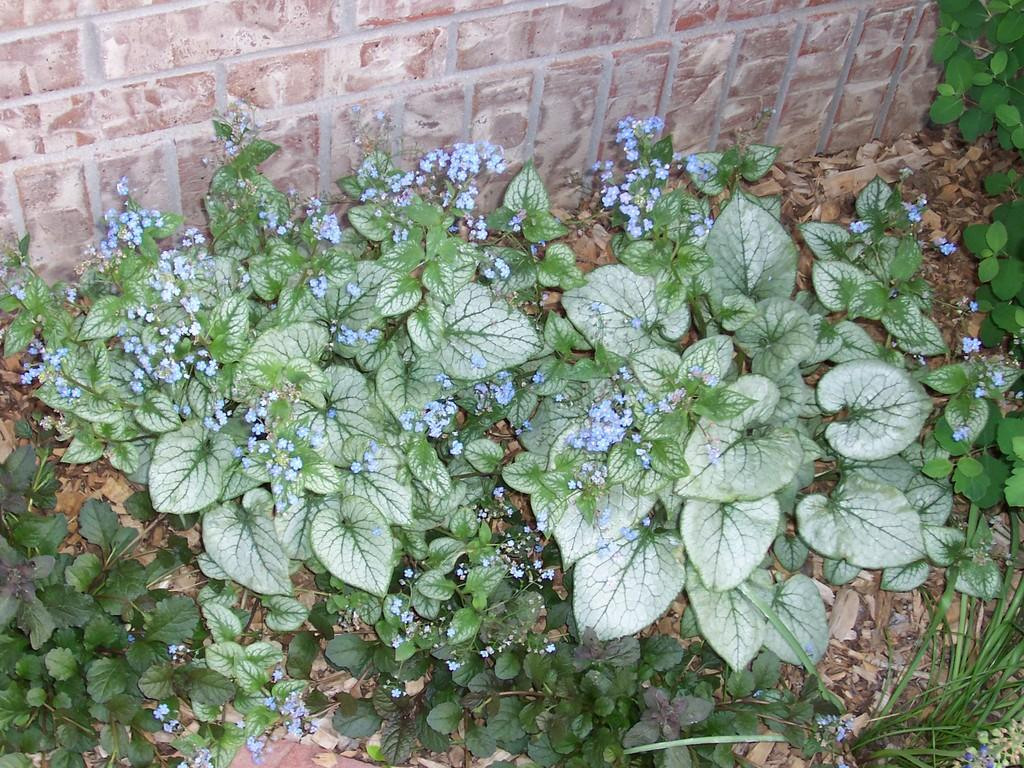What type of vegetation is present on the ground in the image? There are green plants on the ground in the image. What can be seen in the background of the image? There is a brown color granite wall in the background of the image. How many carts are visible in the image? There are no carts present in the image. What type of pies are being served on the chairs in the image? There are no pies or chairs present in the image. 